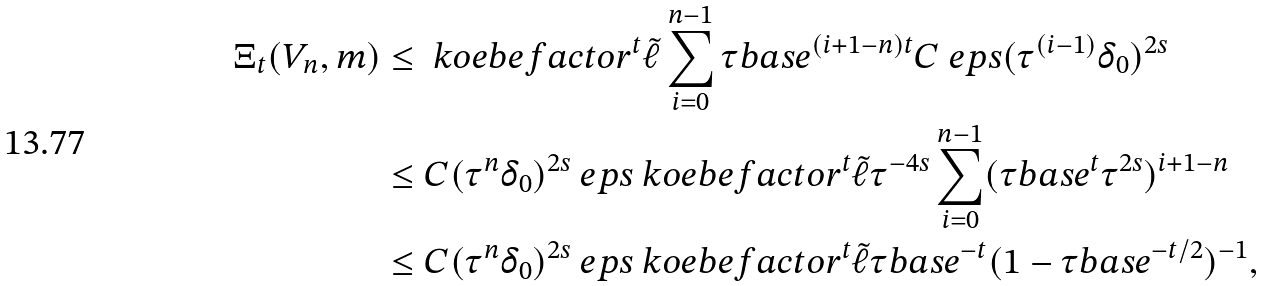Convert formula to latex. <formula><loc_0><loc_0><loc_500><loc_500>\Xi _ { t } ( V _ { n } , m ) & \leq \ k o e b e f a c t o r ^ { t } \tilde { \ell } \sum _ { i = 0 } ^ { n - 1 } \tau b a s e ^ { ( i + 1 - n ) t } C \ e p s ( \tau ^ { ( i - 1 ) } \delta _ { 0 } ) ^ { 2 s } \\ & \leq C ( \tau ^ { n } \delta _ { 0 } ) ^ { 2 s } \ e p s \ k o e b e f a c t o r ^ { t } \tilde { \ell } \tau ^ { - 4 s } \sum _ { i = 0 } ^ { n - 1 } ( \tau b a s e ^ { t } \tau ^ { 2 s } ) ^ { i + 1 - n } \\ & \leq C ( \tau ^ { n } \delta _ { 0 } ) ^ { 2 s } \ e p s \ k o e b e f a c t o r ^ { t } \tilde { \ell } \tau b a s e ^ { - t } ( 1 - \tau b a s e ^ { - t / 2 } ) ^ { - 1 } ,</formula> 